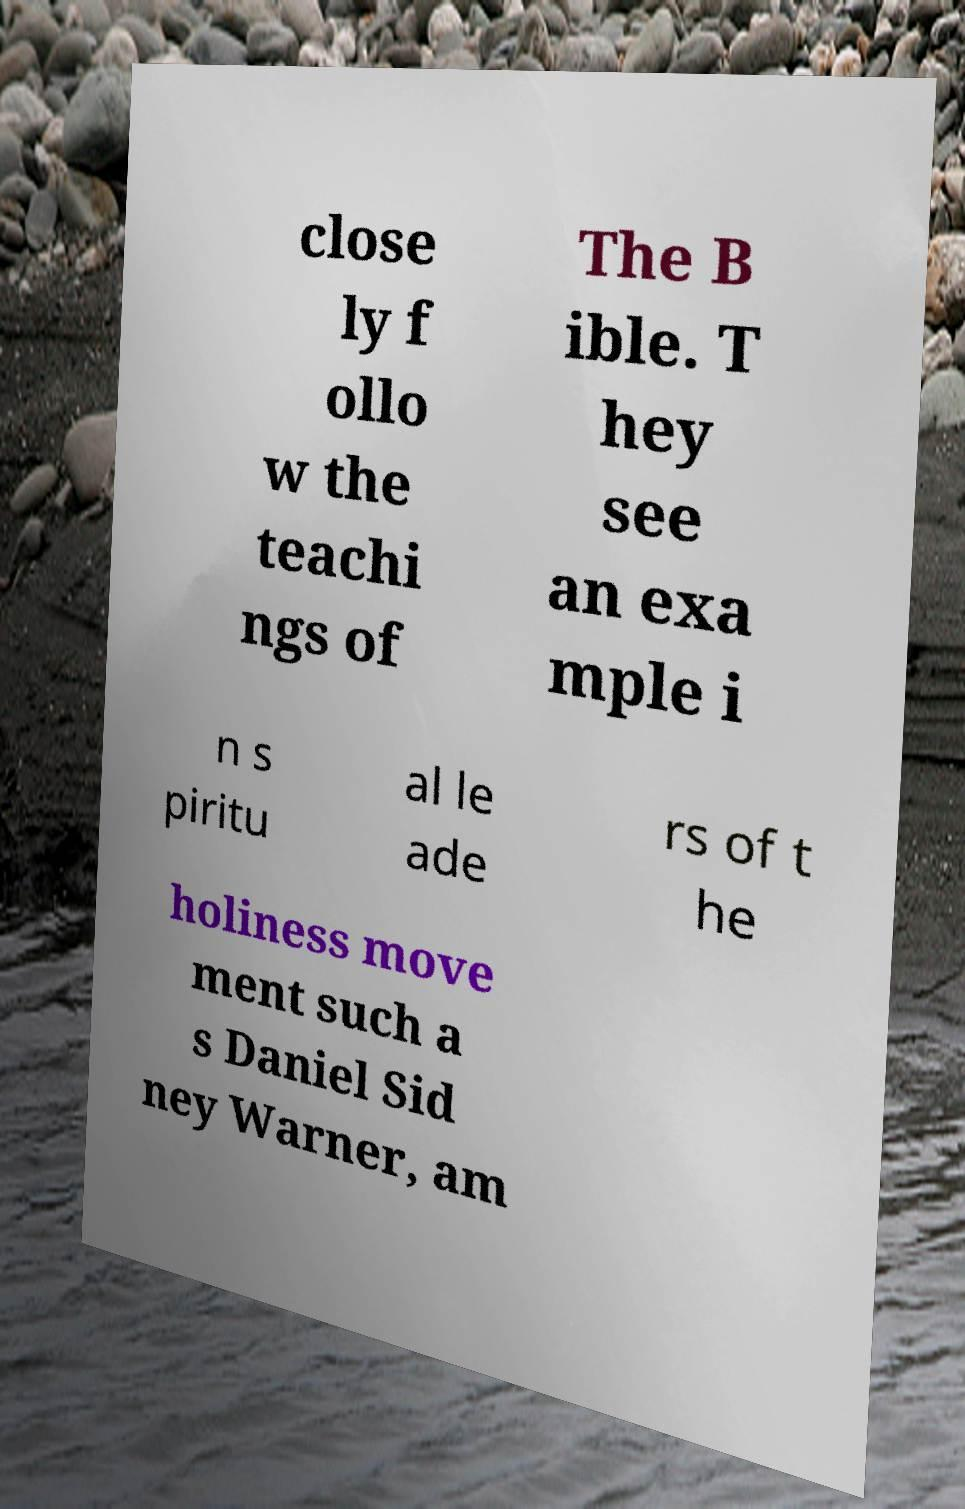Could you extract and type out the text from this image? close ly f ollo w the teachi ngs of The B ible. T hey see an exa mple i n s piritu al le ade rs of t he holiness move ment such a s Daniel Sid ney Warner, am 